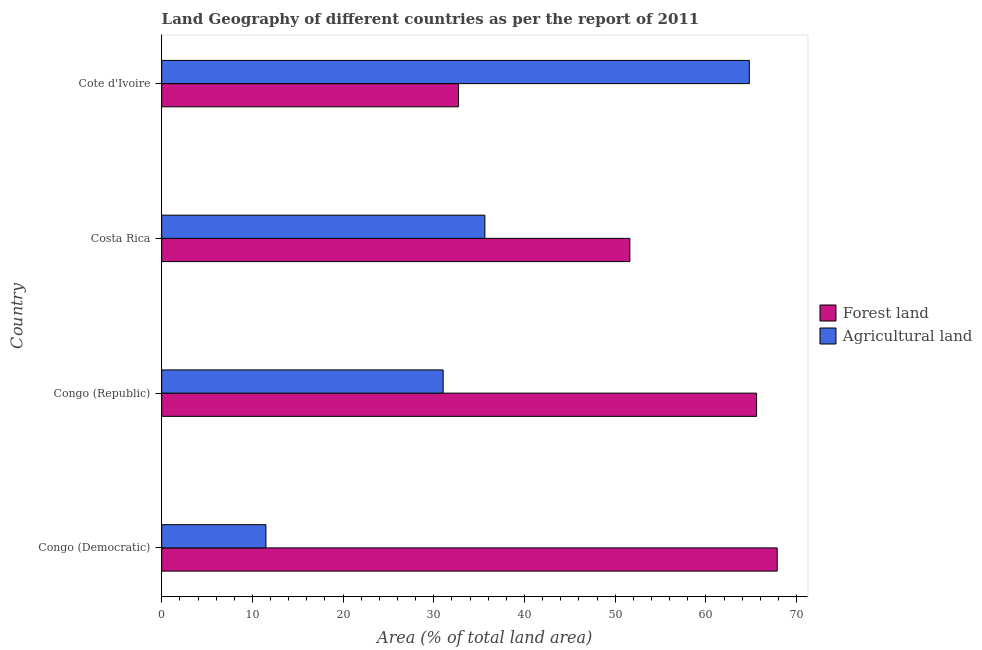How many different coloured bars are there?
Your answer should be compact. 2. Are the number of bars per tick equal to the number of legend labels?
Keep it short and to the point. Yes. Are the number of bars on each tick of the Y-axis equal?
Provide a short and direct response. Yes. How many bars are there on the 2nd tick from the top?
Your response must be concise. 2. How many bars are there on the 4th tick from the bottom?
Make the answer very short. 2. In how many cases, is the number of bars for a given country not equal to the number of legend labels?
Your answer should be compact. 0. What is the percentage of land area under agriculture in Costa Rica?
Provide a short and direct response. 35.62. Across all countries, what is the maximum percentage of land area under agriculture?
Offer a terse response. 64.78. Across all countries, what is the minimum percentage of land area under forests?
Make the answer very short. 32.71. In which country was the percentage of land area under forests maximum?
Your response must be concise. Congo (Democratic). In which country was the percentage of land area under forests minimum?
Offer a very short reply. Cote d'Ivoire. What is the total percentage of land area under agriculture in the graph?
Keep it short and to the point. 142.92. What is the difference between the percentage of land area under agriculture in Costa Rica and that in Cote d'Ivoire?
Make the answer very short. -29.16. What is the difference between the percentage of land area under forests in Costa Rica and the percentage of land area under agriculture in Cote d'Ivoire?
Provide a short and direct response. -13.17. What is the average percentage of land area under agriculture per country?
Ensure brevity in your answer.  35.73. What is the difference between the percentage of land area under agriculture and percentage of land area under forests in Cote d'Ivoire?
Provide a succinct answer. 32.07. What is the ratio of the percentage of land area under forests in Costa Rica to that in Cote d'Ivoire?
Your answer should be compact. 1.58. What is the difference between the highest and the second highest percentage of land area under forests?
Your answer should be compact. 2.27. What is the difference between the highest and the lowest percentage of land area under forests?
Make the answer very short. 35.14. Is the sum of the percentage of land area under agriculture in Congo (Republic) and Costa Rica greater than the maximum percentage of land area under forests across all countries?
Ensure brevity in your answer.  No. What does the 1st bar from the top in Congo (Democratic) represents?
Give a very brief answer. Agricultural land. What does the 2nd bar from the bottom in Congo (Republic) represents?
Your answer should be compact. Agricultural land. What is the difference between two consecutive major ticks on the X-axis?
Give a very brief answer. 10. Does the graph contain grids?
Your response must be concise. No. Where does the legend appear in the graph?
Provide a short and direct response. Center right. How many legend labels are there?
Offer a very short reply. 2. What is the title of the graph?
Make the answer very short. Land Geography of different countries as per the report of 2011. Does "Net savings(excluding particulate emission damage)" appear as one of the legend labels in the graph?
Give a very brief answer. No. What is the label or title of the X-axis?
Make the answer very short. Area (% of total land area). What is the Area (% of total land area) of Forest land in Congo (Democratic)?
Offer a very short reply. 67.85. What is the Area (% of total land area) of Agricultural land in Congo (Democratic)?
Offer a very short reply. 11.49. What is the Area (% of total land area) of Forest land in Congo (Republic)?
Make the answer very short. 65.58. What is the Area (% of total land area) of Agricultural land in Congo (Republic)?
Your answer should be compact. 31.03. What is the Area (% of total land area) in Forest land in Costa Rica?
Offer a terse response. 51.61. What is the Area (% of total land area) of Agricultural land in Costa Rica?
Offer a terse response. 35.62. What is the Area (% of total land area) in Forest land in Cote d'Ivoire?
Offer a very short reply. 32.71. What is the Area (% of total land area) in Agricultural land in Cote d'Ivoire?
Make the answer very short. 64.78. Across all countries, what is the maximum Area (% of total land area) in Forest land?
Ensure brevity in your answer.  67.85. Across all countries, what is the maximum Area (% of total land area) in Agricultural land?
Your answer should be compact. 64.78. Across all countries, what is the minimum Area (% of total land area) of Forest land?
Provide a short and direct response. 32.71. Across all countries, what is the minimum Area (% of total land area) in Agricultural land?
Your response must be concise. 11.49. What is the total Area (% of total land area) in Forest land in the graph?
Provide a short and direct response. 217.75. What is the total Area (% of total land area) of Agricultural land in the graph?
Provide a succinct answer. 142.92. What is the difference between the Area (% of total land area) in Forest land in Congo (Democratic) and that in Congo (Republic)?
Provide a succinct answer. 2.27. What is the difference between the Area (% of total land area) of Agricultural land in Congo (Democratic) and that in Congo (Republic)?
Give a very brief answer. -19.54. What is the difference between the Area (% of total land area) in Forest land in Congo (Democratic) and that in Costa Rica?
Keep it short and to the point. 16.24. What is the difference between the Area (% of total land area) of Agricultural land in Congo (Democratic) and that in Costa Rica?
Offer a very short reply. -24.14. What is the difference between the Area (% of total land area) in Forest land in Congo (Democratic) and that in Cote d'Ivoire?
Ensure brevity in your answer.  35.14. What is the difference between the Area (% of total land area) in Agricultural land in Congo (Democratic) and that in Cote d'Ivoire?
Give a very brief answer. -53.29. What is the difference between the Area (% of total land area) of Forest land in Congo (Republic) and that in Costa Rica?
Offer a very short reply. 13.97. What is the difference between the Area (% of total land area) in Agricultural land in Congo (Republic) and that in Costa Rica?
Keep it short and to the point. -4.6. What is the difference between the Area (% of total land area) of Forest land in Congo (Republic) and that in Cote d'Ivoire?
Your response must be concise. 32.87. What is the difference between the Area (% of total land area) in Agricultural land in Congo (Republic) and that in Cote d'Ivoire?
Give a very brief answer. -33.75. What is the difference between the Area (% of total land area) of Forest land in Costa Rica and that in Cote d'Ivoire?
Your response must be concise. 18.9. What is the difference between the Area (% of total land area) of Agricultural land in Costa Rica and that in Cote d'Ivoire?
Offer a terse response. -29.16. What is the difference between the Area (% of total land area) of Forest land in Congo (Democratic) and the Area (% of total land area) of Agricultural land in Congo (Republic)?
Provide a short and direct response. 36.82. What is the difference between the Area (% of total land area) of Forest land in Congo (Democratic) and the Area (% of total land area) of Agricultural land in Costa Rica?
Provide a short and direct response. 32.23. What is the difference between the Area (% of total land area) of Forest land in Congo (Democratic) and the Area (% of total land area) of Agricultural land in Cote d'Ivoire?
Offer a terse response. 3.07. What is the difference between the Area (% of total land area) in Forest land in Congo (Republic) and the Area (% of total land area) in Agricultural land in Costa Rica?
Offer a terse response. 29.96. What is the difference between the Area (% of total land area) in Forest land in Congo (Republic) and the Area (% of total land area) in Agricultural land in Cote d'Ivoire?
Offer a very short reply. 0.8. What is the difference between the Area (% of total land area) of Forest land in Costa Rica and the Area (% of total land area) of Agricultural land in Cote d'Ivoire?
Ensure brevity in your answer.  -13.17. What is the average Area (% of total land area) in Forest land per country?
Give a very brief answer. 54.44. What is the average Area (% of total land area) of Agricultural land per country?
Provide a short and direct response. 35.73. What is the difference between the Area (% of total land area) in Forest land and Area (% of total land area) in Agricultural land in Congo (Democratic)?
Your answer should be very brief. 56.37. What is the difference between the Area (% of total land area) of Forest land and Area (% of total land area) of Agricultural land in Congo (Republic)?
Provide a short and direct response. 34.55. What is the difference between the Area (% of total land area) in Forest land and Area (% of total land area) in Agricultural land in Costa Rica?
Your answer should be compact. 15.99. What is the difference between the Area (% of total land area) in Forest land and Area (% of total land area) in Agricultural land in Cote d'Ivoire?
Your response must be concise. -32.07. What is the ratio of the Area (% of total land area) of Forest land in Congo (Democratic) to that in Congo (Republic)?
Keep it short and to the point. 1.03. What is the ratio of the Area (% of total land area) in Agricultural land in Congo (Democratic) to that in Congo (Republic)?
Give a very brief answer. 0.37. What is the ratio of the Area (% of total land area) in Forest land in Congo (Democratic) to that in Costa Rica?
Keep it short and to the point. 1.31. What is the ratio of the Area (% of total land area) of Agricultural land in Congo (Democratic) to that in Costa Rica?
Your response must be concise. 0.32. What is the ratio of the Area (% of total land area) in Forest land in Congo (Democratic) to that in Cote d'Ivoire?
Your answer should be very brief. 2.07. What is the ratio of the Area (% of total land area) in Agricultural land in Congo (Democratic) to that in Cote d'Ivoire?
Make the answer very short. 0.18. What is the ratio of the Area (% of total land area) in Forest land in Congo (Republic) to that in Costa Rica?
Keep it short and to the point. 1.27. What is the ratio of the Area (% of total land area) of Agricultural land in Congo (Republic) to that in Costa Rica?
Keep it short and to the point. 0.87. What is the ratio of the Area (% of total land area) in Forest land in Congo (Republic) to that in Cote d'Ivoire?
Offer a terse response. 2. What is the ratio of the Area (% of total land area) in Agricultural land in Congo (Republic) to that in Cote d'Ivoire?
Give a very brief answer. 0.48. What is the ratio of the Area (% of total land area) in Forest land in Costa Rica to that in Cote d'Ivoire?
Your answer should be compact. 1.58. What is the ratio of the Area (% of total land area) in Agricultural land in Costa Rica to that in Cote d'Ivoire?
Your response must be concise. 0.55. What is the difference between the highest and the second highest Area (% of total land area) of Forest land?
Offer a very short reply. 2.27. What is the difference between the highest and the second highest Area (% of total land area) in Agricultural land?
Your answer should be compact. 29.16. What is the difference between the highest and the lowest Area (% of total land area) of Forest land?
Ensure brevity in your answer.  35.14. What is the difference between the highest and the lowest Area (% of total land area) of Agricultural land?
Ensure brevity in your answer.  53.29. 